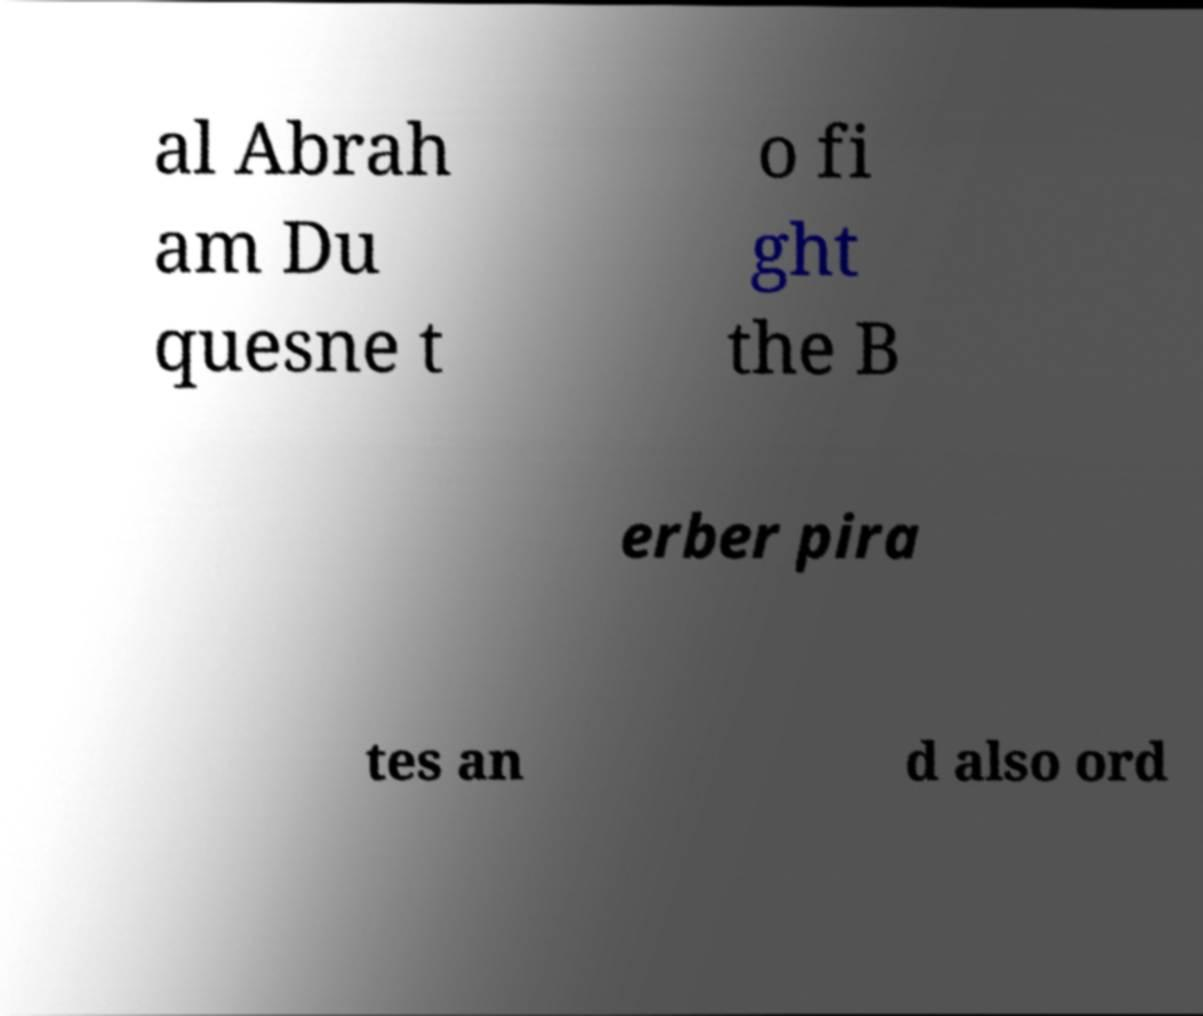There's text embedded in this image that I need extracted. Can you transcribe it verbatim? al Abrah am Du quesne t o fi ght the B erber pira tes an d also ord 